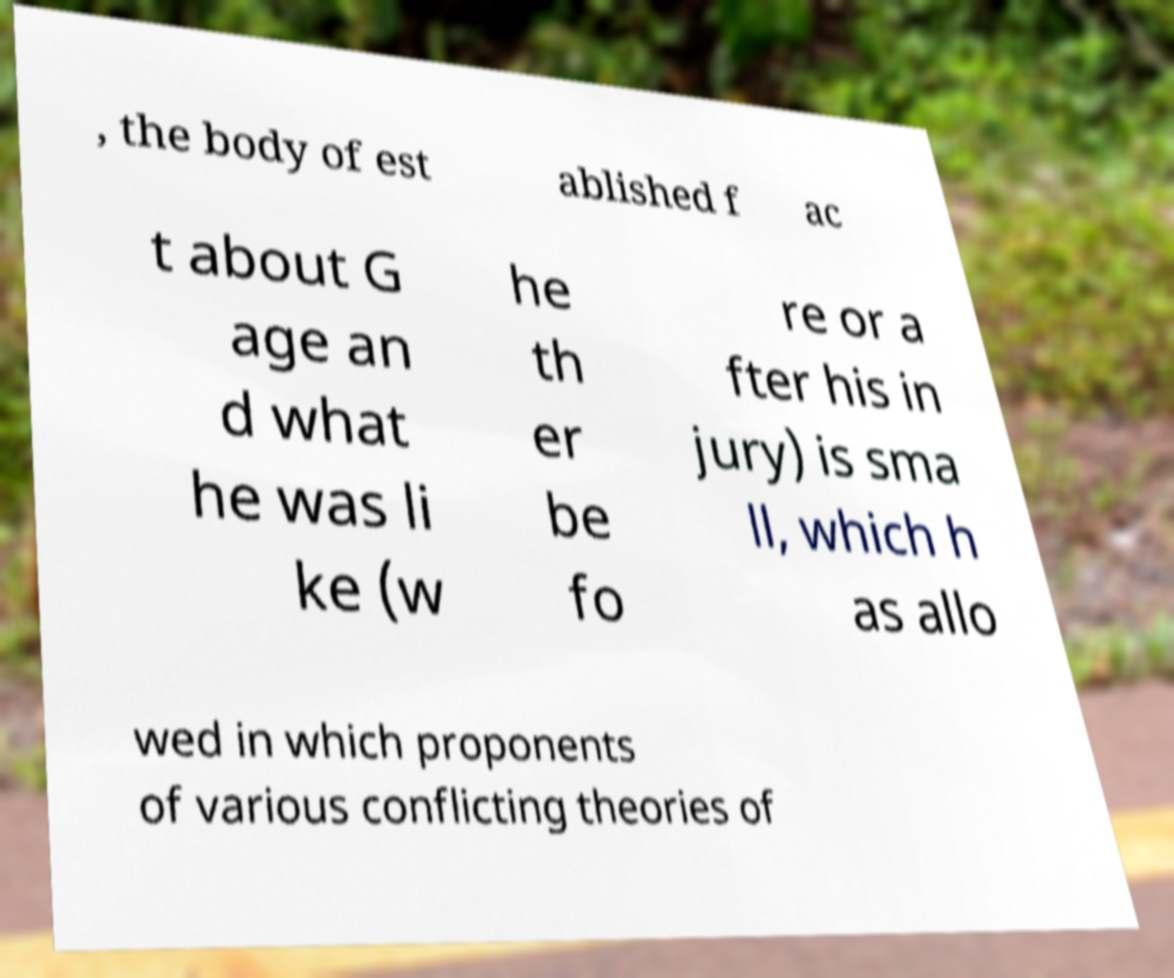Please identify and transcribe the text found in this image. , the body of est ablished f ac t about G age an d what he was li ke (w he th er be fo re or a fter his in jury) is sma ll, which h as allo wed in which proponents of various conflicting theories of 